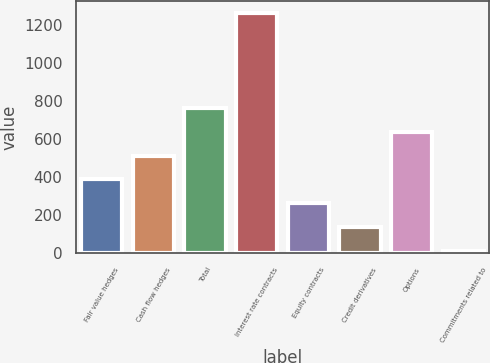<chart> <loc_0><loc_0><loc_500><loc_500><bar_chart><fcel>Fair value hedges<fcel>Cash flow hedges<fcel>Total<fcel>Interest rate contracts<fcel>Equity contracts<fcel>Credit derivatives<fcel>Options<fcel>Commitments related to<nl><fcel>388.2<fcel>512.6<fcel>761.4<fcel>1259<fcel>263.8<fcel>139.4<fcel>637<fcel>15<nl></chart> 